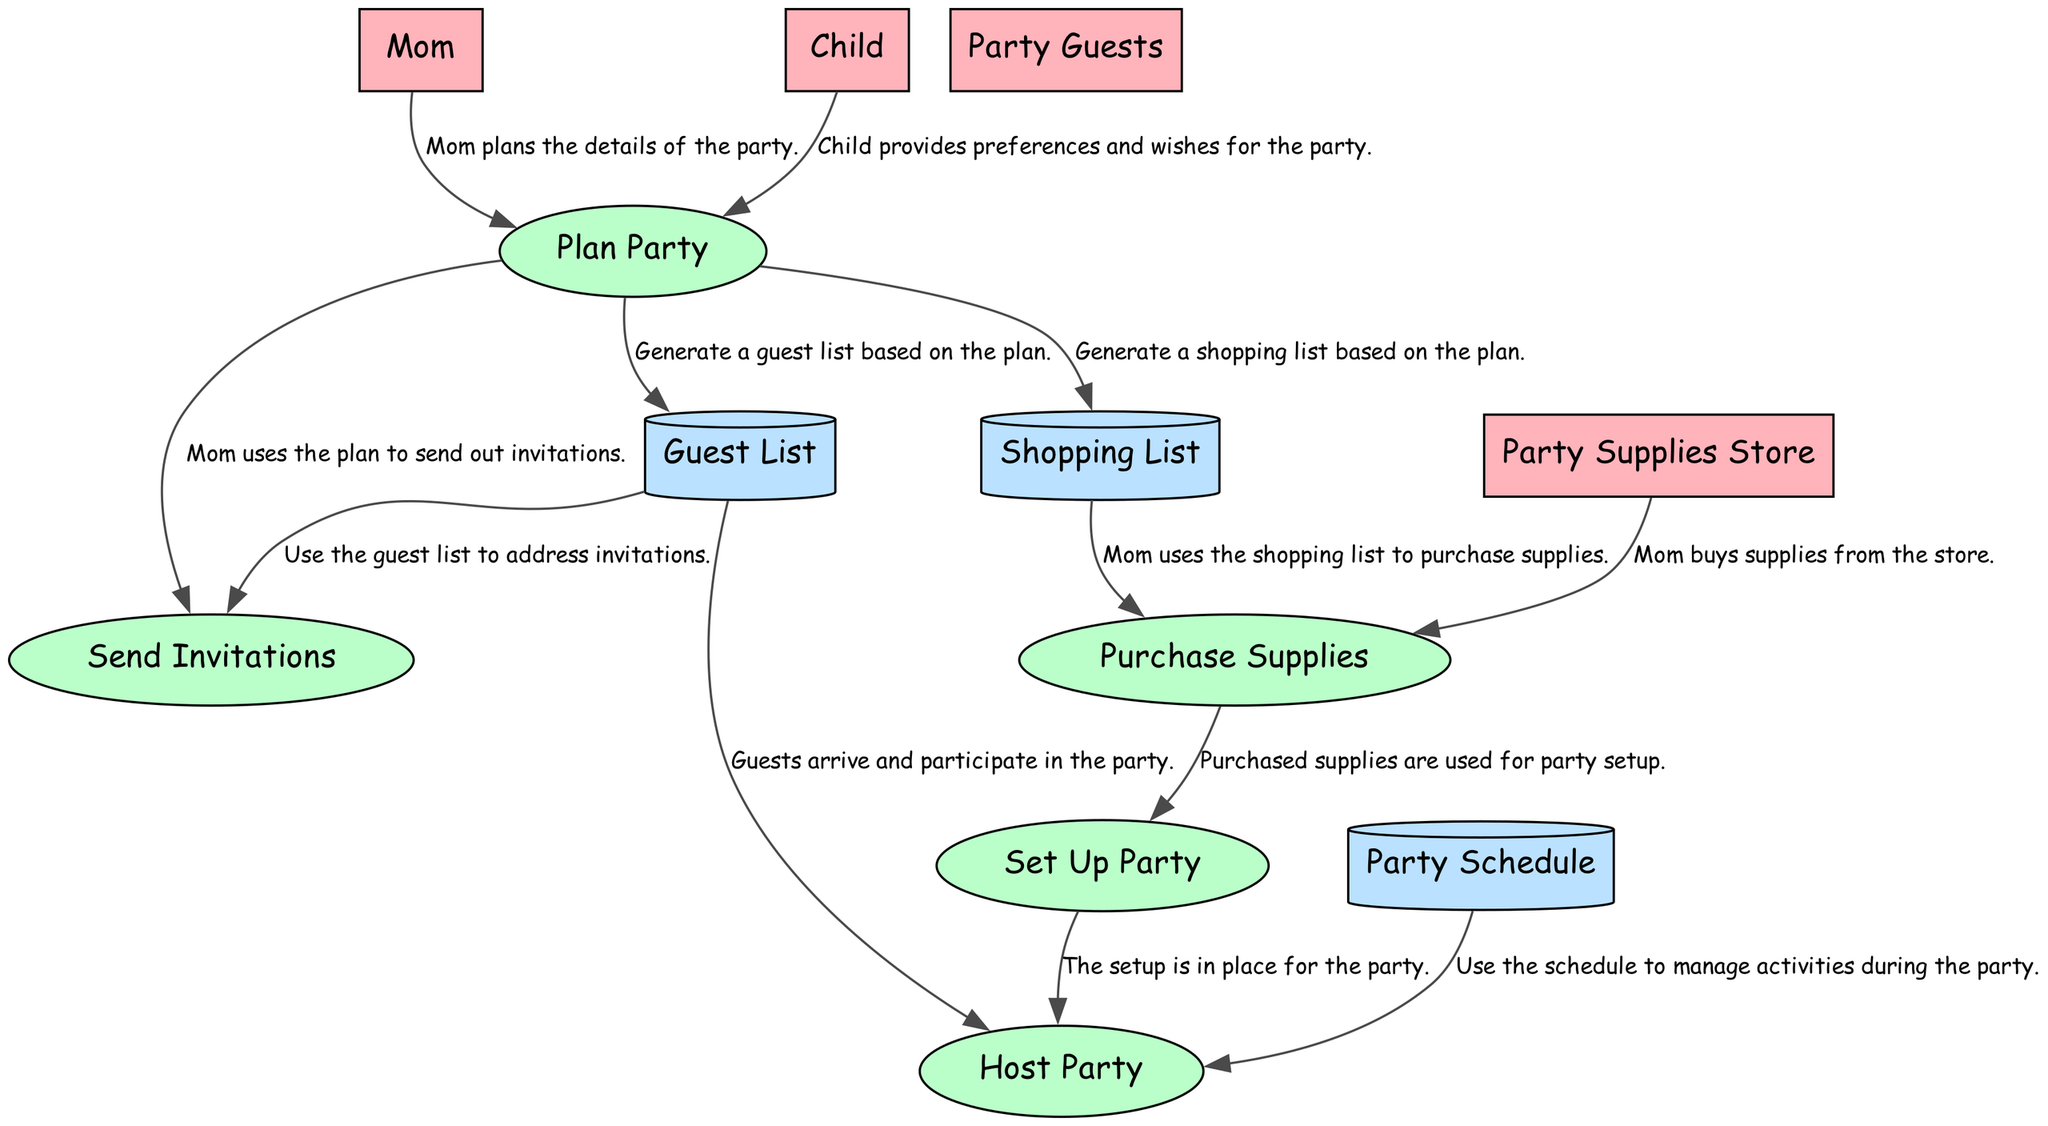What is the name of the external entity that plans the party? The diagram identifies "Mom" as the external entity responsible for planning the party. It shows her at the start of the process, indicating her role in initiating the party planning, clearly confirming her designation as the planner.
Answer: Mom How many processes are involved in planning the party? The diagram outlines five distinct processes: "Plan Party," "Send Invitations," "Purchase Supplies," "Set Up Party," and "Host Party." Counting these processes provides an understanding of the overall planning and execution activities involved for the birthday party.
Answer: 5 What is the purpose of the "Guest List" data store? The "Guest List" serves as a storage location for the names and contact information of invited guests, which is utilized during the invitation process. This highlights its role in helping the mom send out invitations efficiently based on the planned details.
Answer: A list of names and contact information of the invited guests Which external entity provides preferences for the party? "Child" is noted as the external entity that communicates preferences and wishes regarding the party. In the flow, the child's input is directed towards the planning process, demonstrating their engagement in the event's organization.
Answer: Child What information does the "Shopping List" data store provide? The "Shopping List" contains crucial items that need to be purchased for the birthday party, aiding in the procurement process. This data directly supports the "Purchase Supplies" process, indicating its importance in the preparation stage of the event.
Answer: A list of items needed to be purchased for the party What does the process "Set Up Party" depend on? The "Set Up Party" process relies on inputs from both the "Purchase Supplies" process and the "Guest List" to ensure that everything is prepared before hosting the event. The completion of supply purchases and organization of guests are essential steps leading into setup.
Answer: Purchased supplies and guest participation How does "Send Invitations" utilize the "Guest List"? The "Send Invitations" process uses the "Guest List" to address invitations, demonstrating a clear flow of information where the guest details are directly applied to the invitation task. This relationship emphasizes the importance of having an accurate guest list for efficient communication.
Answer: Use the guest list to address invitations What is the final process of the birthday party planning workflow? "Host Party" is identified as the concluding process in the workflow for organizing the birthday party. This signifies that all prior preparations are completed and now culminate in the execution of hosting for the guests arriving at the party.
Answer: Host Party 